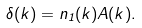Convert formula to latex. <formula><loc_0><loc_0><loc_500><loc_500>\delta ( { k } ) = n _ { 1 } ( { k } ) A ( { k } ) .</formula> 